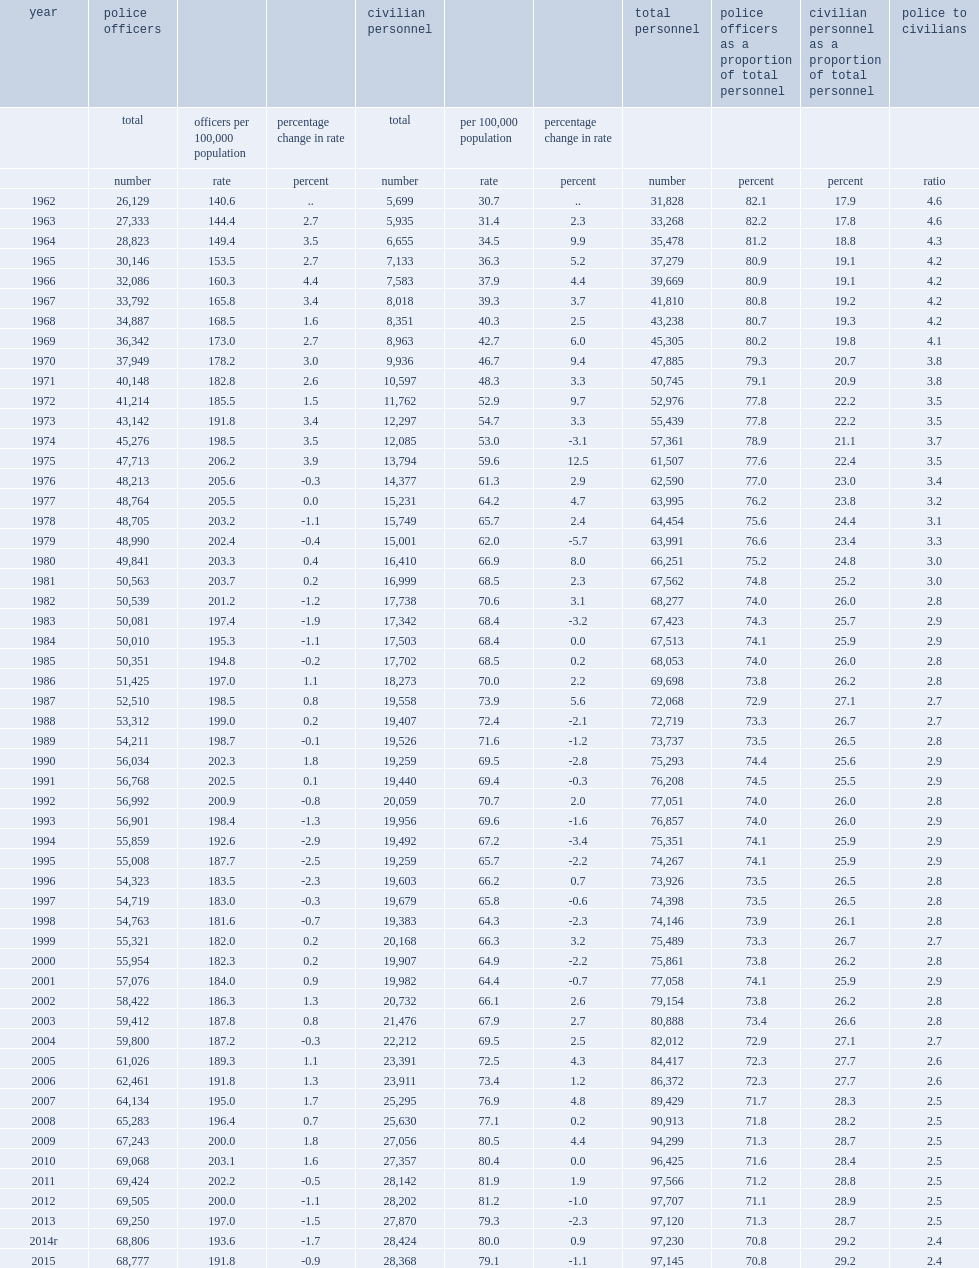What is the number of police officers in canada on may 15, 2015? 68777.0. What is the number of officers per 1000,000 population in canada on may 15, 2015? 191.8. 